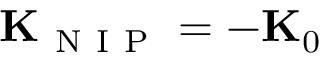<formula> <loc_0><loc_0><loc_500><loc_500>{ K } _ { N I P } = - { K } _ { 0 }</formula> 